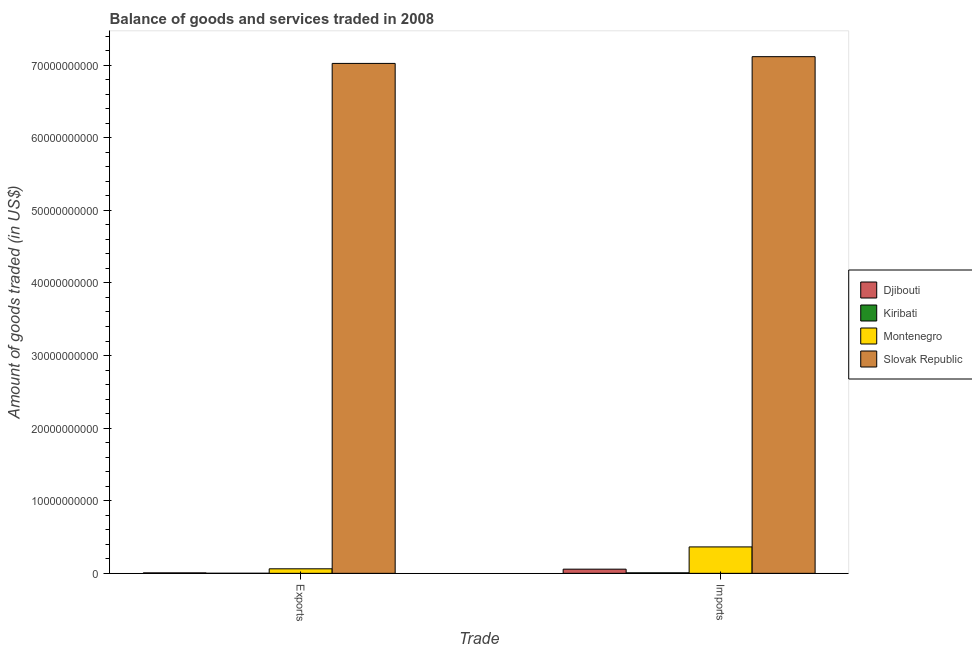How many different coloured bars are there?
Keep it short and to the point. 4. How many groups of bars are there?
Provide a succinct answer. 2. Are the number of bars per tick equal to the number of legend labels?
Make the answer very short. Yes. What is the label of the 2nd group of bars from the left?
Your response must be concise. Imports. What is the amount of goods exported in Kiribati?
Provide a short and direct response. 9.18e+06. Across all countries, what is the maximum amount of goods imported?
Keep it short and to the point. 7.12e+1. Across all countries, what is the minimum amount of goods exported?
Offer a terse response. 9.18e+06. In which country was the amount of goods exported maximum?
Provide a succinct answer. Slovak Republic. In which country was the amount of goods exported minimum?
Offer a terse response. Kiribati. What is the total amount of goods imported in the graph?
Your answer should be compact. 7.55e+1. What is the difference between the amount of goods imported in Montenegro and that in Slovak Republic?
Provide a short and direct response. -6.75e+1. What is the difference between the amount of goods imported in Kiribati and the amount of goods exported in Slovak Republic?
Give a very brief answer. -7.02e+1. What is the average amount of goods exported per country?
Provide a succinct answer. 1.77e+1. What is the difference between the amount of goods exported and amount of goods imported in Kiribati?
Offer a terse response. -6.04e+07. What is the ratio of the amount of goods exported in Djibouti to that in Montenegro?
Ensure brevity in your answer.  0.1. In how many countries, is the amount of goods imported greater than the average amount of goods imported taken over all countries?
Give a very brief answer. 1. What does the 4th bar from the left in Exports represents?
Your response must be concise. Slovak Republic. What does the 2nd bar from the right in Imports represents?
Offer a terse response. Montenegro. Are all the bars in the graph horizontal?
Your answer should be compact. No. Does the graph contain any zero values?
Keep it short and to the point. No. Where does the legend appear in the graph?
Your response must be concise. Center right. What is the title of the graph?
Your response must be concise. Balance of goods and services traded in 2008. What is the label or title of the X-axis?
Provide a succinct answer. Trade. What is the label or title of the Y-axis?
Your answer should be very brief. Amount of goods traded (in US$). What is the Amount of goods traded (in US$) of Djibouti in Exports?
Offer a terse response. 6.38e+07. What is the Amount of goods traded (in US$) of Kiribati in Exports?
Your response must be concise. 9.18e+06. What is the Amount of goods traded (in US$) of Montenegro in Exports?
Give a very brief answer. 6.23e+08. What is the Amount of goods traded (in US$) in Slovak Republic in Exports?
Your response must be concise. 7.02e+1. What is the Amount of goods traded (in US$) of Djibouti in Imports?
Offer a very short reply. 5.74e+08. What is the Amount of goods traded (in US$) of Kiribati in Imports?
Your answer should be very brief. 6.96e+07. What is the Amount of goods traded (in US$) of Montenegro in Imports?
Provide a succinct answer. 3.64e+09. What is the Amount of goods traded (in US$) of Slovak Republic in Imports?
Offer a terse response. 7.12e+1. Across all Trade, what is the maximum Amount of goods traded (in US$) of Djibouti?
Give a very brief answer. 5.74e+08. Across all Trade, what is the maximum Amount of goods traded (in US$) in Kiribati?
Offer a terse response. 6.96e+07. Across all Trade, what is the maximum Amount of goods traded (in US$) of Montenegro?
Keep it short and to the point. 3.64e+09. Across all Trade, what is the maximum Amount of goods traded (in US$) in Slovak Republic?
Give a very brief answer. 7.12e+1. Across all Trade, what is the minimum Amount of goods traded (in US$) in Djibouti?
Your answer should be very brief. 6.38e+07. Across all Trade, what is the minimum Amount of goods traded (in US$) of Kiribati?
Provide a short and direct response. 9.18e+06. Across all Trade, what is the minimum Amount of goods traded (in US$) in Montenegro?
Make the answer very short. 6.23e+08. Across all Trade, what is the minimum Amount of goods traded (in US$) of Slovak Republic?
Provide a succinct answer. 7.02e+1. What is the total Amount of goods traded (in US$) of Djibouti in the graph?
Make the answer very short. 6.38e+08. What is the total Amount of goods traded (in US$) of Kiribati in the graph?
Provide a short and direct response. 7.88e+07. What is the total Amount of goods traded (in US$) of Montenegro in the graph?
Ensure brevity in your answer.  4.26e+09. What is the total Amount of goods traded (in US$) in Slovak Republic in the graph?
Provide a short and direct response. 1.41e+11. What is the difference between the Amount of goods traded (in US$) in Djibouti in Exports and that in Imports?
Offer a very short reply. -5.10e+08. What is the difference between the Amount of goods traded (in US$) in Kiribati in Exports and that in Imports?
Provide a succinct answer. -6.04e+07. What is the difference between the Amount of goods traded (in US$) in Montenegro in Exports and that in Imports?
Your answer should be very brief. -3.02e+09. What is the difference between the Amount of goods traded (in US$) of Slovak Republic in Exports and that in Imports?
Ensure brevity in your answer.  -9.30e+08. What is the difference between the Amount of goods traded (in US$) of Djibouti in Exports and the Amount of goods traded (in US$) of Kiribati in Imports?
Your answer should be very brief. -5.82e+06. What is the difference between the Amount of goods traded (in US$) of Djibouti in Exports and the Amount of goods traded (in US$) of Montenegro in Imports?
Give a very brief answer. -3.58e+09. What is the difference between the Amount of goods traded (in US$) in Djibouti in Exports and the Amount of goods traded (in US$) in Slovak Republic in Imports?
Your response must be concise. -7.11e+1. What is the difference between the Amount of goods traded (in US$) of Kiribati in Exports and the Amount of goods traded (in US$) of Montenegro in Imports?
Ensure brevity in your answer.  -3.63e+09. What is the difference between the Amount of goods traded (in US$) in Kiribati in Exports and the Amount of goods traded (in US$) in Slovak Republic in Imports?
Provide a succinct answer. -7.12e+1. What is the difference between the Amount of goods traded (in US$) in Montenegro in Exports and the Amount of goods traded (in US$) in Slovak Republic in Imports?
Provide a short and direct response. -7.05e+1. What is the average Amount of goods traded (in US$) in Djibouti per Trade?
Your answer should be compact. 3.19e+08. What is the average Amount of goods traded (in US$) of Kiribati per Trade?
Make the answer very short. 3.94e+07. What is the average Amount of goods traded (in US$) in Montenegro per Trade?
Ensure brevity in your answer.  2.13e+09. What is the average Amount of goods traded (in US$) of Slovak Republic per Trade?
Make the answer very short. 7.07e+1. What is the difference between the Amount of goods traded (in US$) of Djibouti and Amount of goods traded (in US$) of Kiribati in Exports?
Provide a succinct answer. 5.46e+07. What is the difference between the Amount of goods traded (in US$) in Djibouti and Amount of goods traded (in US$) in Montenegro in Exports?
Your response must be concise. -5.59e+08. What is the difference between the Amount of goods traded (in US$) of Djibouti and Amount of goods traded (in US$) of Slovak Republic in Exports?
Offer a terse response. -7.02e+1. What is the difference between the Amount of goods traded (in US$) in Kiribati and Amount of goods traded (in US$) in Montenegro in Exports?
Offer a very short reply. -6.14e+08. What is the difference between the Amount of goods traded (in US$) in Kiribati and Amount of goods traded (in US$) in Slovak Republic in Exports?
Your response must be concise. -7.02e+1. What is the difference between the Amount of goods traded (in US$) of Montenegro and Amount of goods traded (in US$) of Slovak Republic in Exports?
Offer a terse response. -6.96e+1. What is the difference between the Amount of goods traded (in US$) in Djibouti and Amount of goods traded (in US$) in Kiribati in Imports?
Give a very brief answer. 5.05e+08. What is the difference between the Amount of goods traded (in US$) in Djibouti and Amount of goods traded (in US$) in Montenegro in Imports?
Your answer should be very brief. -3.07e+09. What is the difference between the Amount of goods traded (in US$) of Djibouti and Amount of goods traded (in US$) of Slovak Republic in Imports?
Your response must be concise. -7.06e+1. What is the difference between the Amount of goods traded (in US$) of Kiribati and Amount of goods traded (in US$) of Montenegro in Imports?
Ensure brevity in your answer.  -3.57e+09. What is the difference between the Amount of goods traded (in US$) in Kiribati and Amount of goods traded (in US$) in Slovak Republic in Imports?
Offer a terse response. -7.11e+1. What is the difference between the Amount of goods traded (in US$) of Montenegro and Amount of goods traded (in US$) of Slovak Republic in Imports?
Provide a short and direct response. -6.75e+1. What is the ratio of the Amount of goods traded (in US$) of Djibouti in Exports to that in Imports?
Make the answer very short. 0.11. What is the ratio of the Amount of goods traded (in US$) of Kiribati in Exports to that in Imports?
Your answer should be very brief. 0.13. What is the ratio of the Amount of goods traded (in US$) in Montenegro in Exports to that in Imports?
Keep it short and to the point. 0.17. What is the ratio of the Amount of goods traded (in US$) of Slovak Republic in Exports to that in Imports?
Provide a short and direct response. 0.99. What is the difference between the highest and the second highest Amount of goods traded (in US$) in Djibouti?
Provide a short and direct response. 5.10e+08. What is the difference between the highest and the second highest Amount of goods traded (in US$) of Kiribati?
Give a very brief answer. 6.04e+07. What is the difference between the highest and the second highest Amount of goods traded (in US$) of Montenegro?
Provide a succinct answer. 3.02e+09. What is the difference between the highest and the second highest Amount of goods traded (in US$) of Slovak Republic?
Provide a succinct answer. 9.30e+08. What is the difference between the highest and the lowest Amount of goods traded (in US$) in Djibouti?
Give a very brief answer. 5.10e+08. What is the difference between the highest and the lowest Amount of goods traded (in US$) of Kiribati?
Ensure brevity in your answer.  6.04e+07. What is the difference between the highest and the lowest Amount of goods traded (in US$) in Montenegro?
Provide a short and direct response. 3.02e+09. What is the difference between the highest and the lowest Amount of goods traded (in US$) in Slovak Republic?
Ensure brevity in your answer.  9.30e+08. 